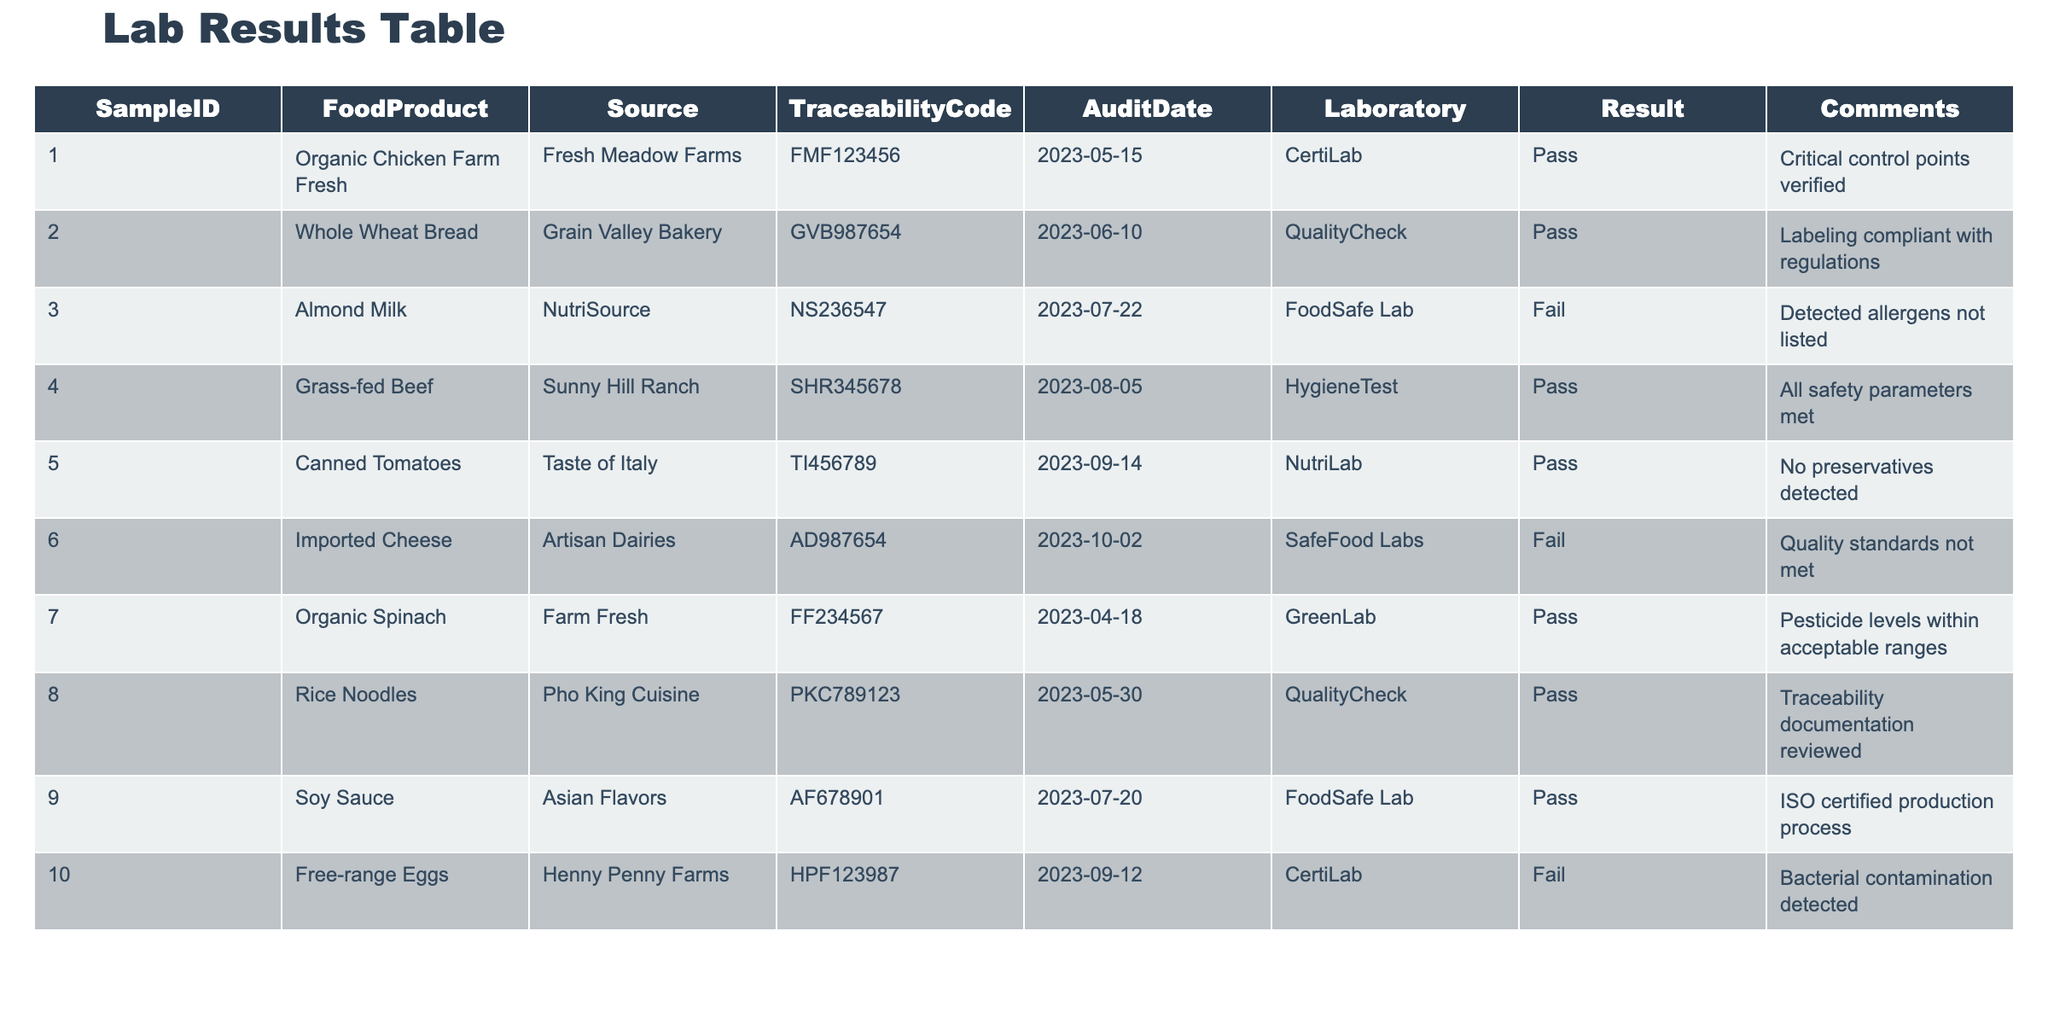What is the source of the food product with Sample ID 003? The table shows that Sample ID 003 corresponds to Almond Milk, and its source is listed as NutriSource.
Answer: NutriSource How many food products failed the lab tests? From the table, we can see that two food products indicated a "Fail" result: Almond Milk and Imported Cheese, and Free-range Eggs. Hence, the total count is 3.
Answer: 3 Is there any product that passed while having a traceability code starting with "F"? Examining the table, we find that Organic Chicken Farm Fresh (Sample ID 001) and Organic Spinach (Sample ID 007) both have traceability codes starting with "F" and they both passed the audit.
Answer: Yes What percentage of food products passed the lab test? There are 10 total products listed in the table, and 7 of them passed (Sample IDs 001, 002, 004, 005, 008, 009, and 007). To find the percentage, we calculate (7/10) * 100 = 70%.
Answer: 70% Which laboratory conducted the audit for the Canned Tomatoes? According to the table, the laboratory that conducted the audit for Canned Tomatoes (Sample ID 005) is listed as NutriLab.
Answer: NutriLab What is the comment associated with the Free-range Eggs? The row for Free-range Eggs (Sample ID 010) includes a comment stating "Bacterial contamination detected."
Answer: Bacterial contamination detected How many different laboratories conducted audits for the samples listed? By reviewing the table, we find that there are five different laboratories mentioned: CertiLab, QualityCheck, FoodSafe Lab, HygieneTest, and SafeFood Labs, totaling to 5 different labs.
Answer: 5 What observation can be made about the food product with the Traceability Code "FMF123456"? The table indicates that the food product with Traceability Code "FMF123456" is Organic Chicken Farm Fresh, which passed the audit with critical control points verified.
Answer: Passed with critical control points verified What are the names of food products that passed the lab test? By reviewing the table, the food products that passed include Organic Chicken Farm Fresh, Whole Wheat Bread, Grass-fed Beef, Canned Tomatoes, Organic Spinach, Rice Noodles, and Soy Sauce. We have a total of 7 products that passed.
Answer: 7 products passed 